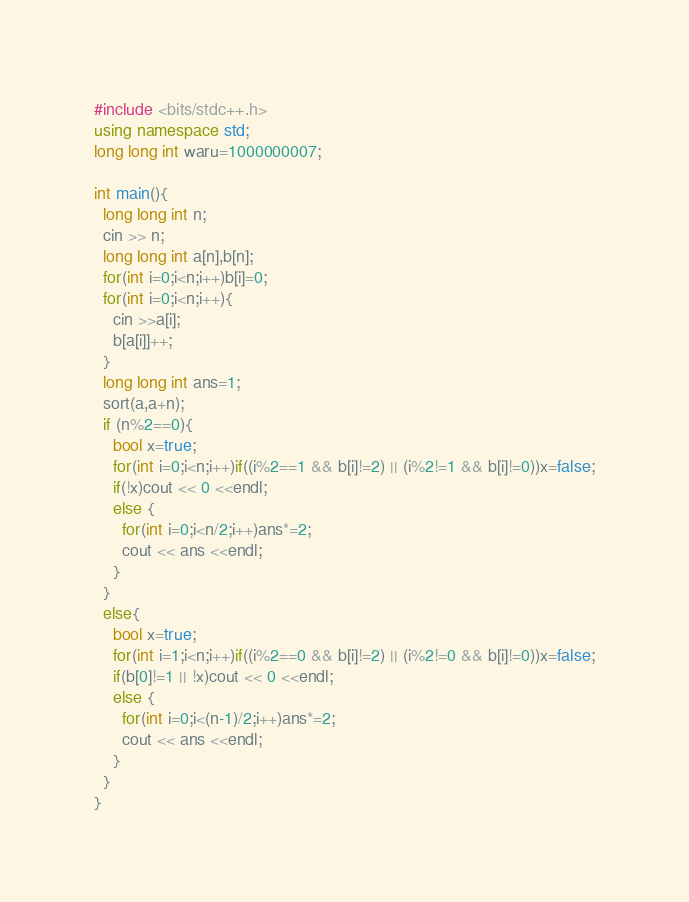Convert code to text. <code><loc_0><loc_0><loc_500><loc_500><_C++_>#include <bits/stdc++.h>
using namespace std;
long long int waru=1000000007;

int main(){
  long long int n;
  cin >> n;
  long long int a[n],b[n];
  for(int i=0;i<n;i++)b[i]=0;
  for(int i=0;i<n;i++){
    cin >>a[i];
    b[a[i]]++;
  }
  long long int ans=1;
  sort(a,a+n);
  if (n%2==0){
    bool x=true;
    for(int i=0;i<n;i++)if((i%2==1 && b[i]!=2) || (i%2!=1 && b[i]!=0))x=false;
    if(!x)cout << 0 <<endl;
    else {
      for(int i=0;i<n/2;i++)ans*=2;
      cout << ans <<endl;
    }
  }
  else{
    bool x=true;
    for(int i=1;i<n;i++)if((i%2==0 && b[i]!=2) || (i%2!=0 && b[i]!=0))x=false;
    if(b[0]!=1 || !x)cout << 0 <<endl;
    else {
      for(int i=0;i<(n-1)/2;i++)ans*=2;
      cout << ans <<endl;
    }
  }
}
</code> 